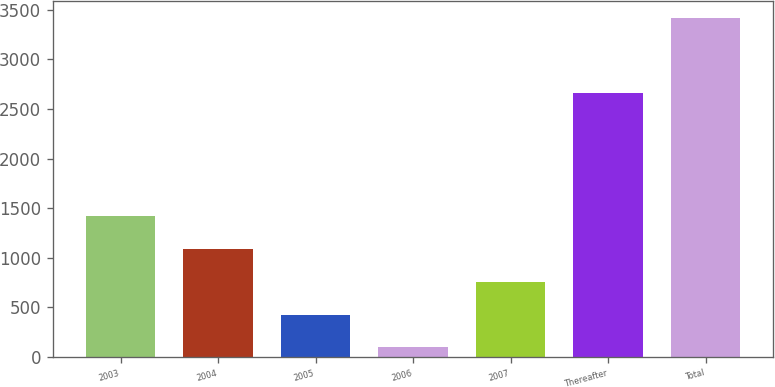Convert chart to OTSL. <chart><loc_0><loc_0><loc_500><loc_500><bar_chart><fcel>2003<fcel>2004<fcel>2005<fcel>2006<fcel>2007<fcel>Thereafter<fcel>Total<nl><fcel>1423.6<fcel>1091.7<fcel>427.9<fcel>96<fcel>759.8<fcel>2659<fcel>3415<nl></chart> 